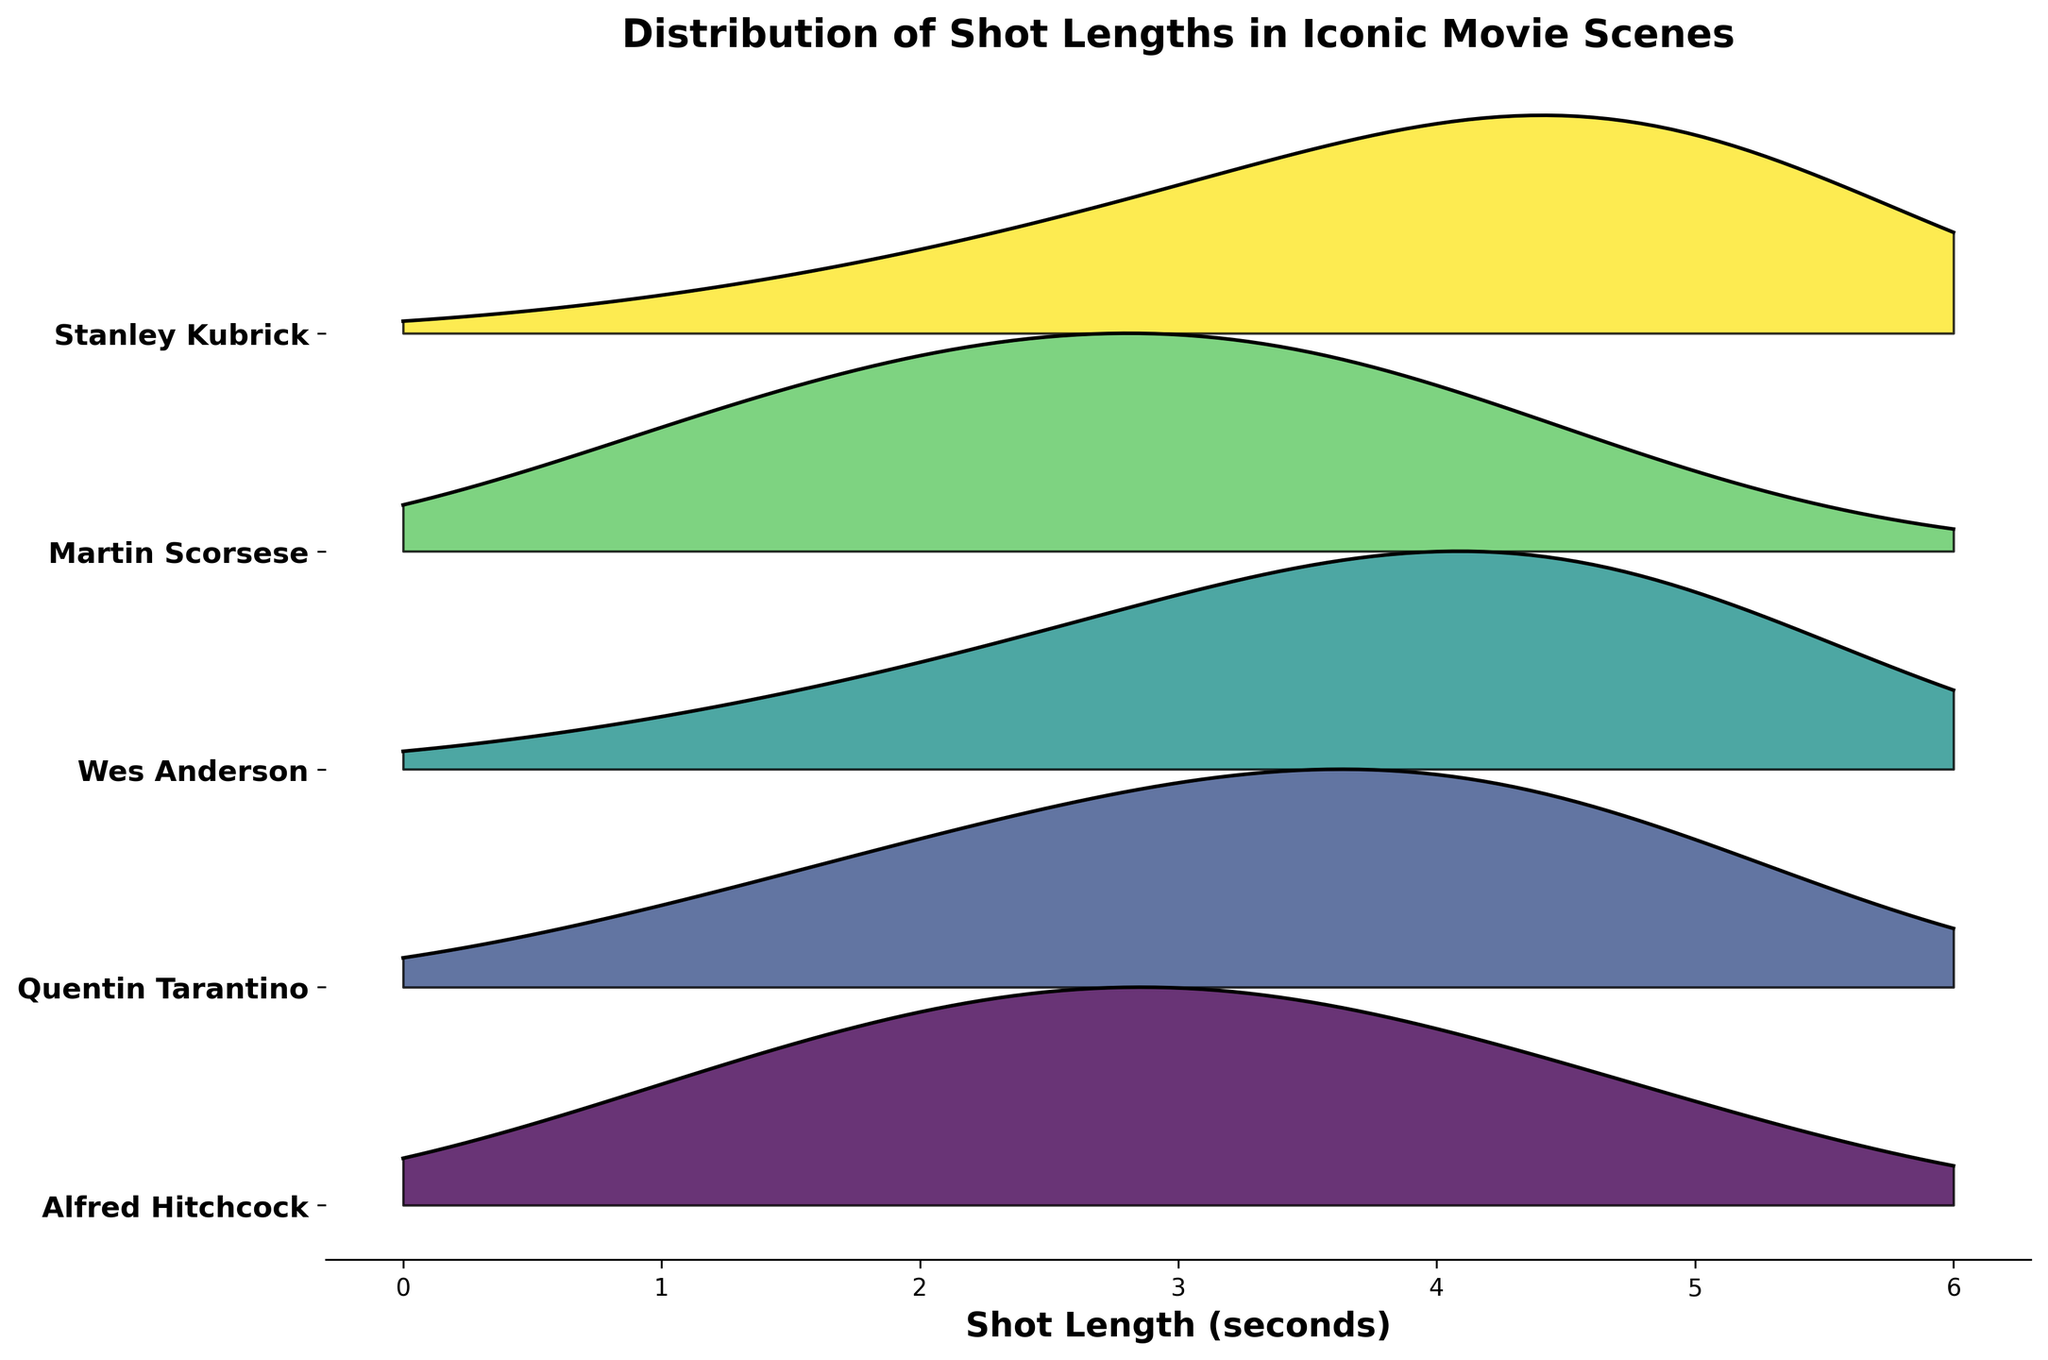What is the title of the figure? The title can be found at the top of the figure and usually summarizes the main topic or insight being presented.
Answer: Distribution of Shot Lengths in Iconic Movie Scenes Which director has the highest frequency for the shortest shot length? Inspect the ridgeline plot for the highest peaks at the shortest shot length, which in this case is 1 second. Count the frequency of the highest director.
Answer: Alfred Hitchcock What is the shot length with the highest frequency in Wes Anderson's data? Look at the shape of the ridgeline for Wes Anderson and identify the highest peak or density. Follow the x-axis to locate the corresponding shot length in seconds.
Answer: 4 seconds How do Quentin Tarantino's shot length distributions compare to Alfred Hitchcock's? Observe the ridgeline plots of both directors, specifically comparing the peaks and distributions of shot lengths. Quentin Tarantino shows higher frequencies for longer shot lengths than Alfred Hitchcock.
Answer: Longer shot lengths are more frequent What is the range of shot lengths examined in this figure? Identify the minimum and maximum values along the x-axis, which represent the shot lengths in the figure.
Answer: 1 to 5 seconds Which director has the most even distribution of shot lengths? Analyze the ridgeline plots for each director to see which has a more uniform spread without a pronounced peak. Stanley Kubrick's plot demonstrates a more even distribution across different shot lengths.
Answer: Stanley Kubrick Among the directors, who uses the longest shot length most frequently? Examine the peaks in the ridgeline plots and identify which director has the highest peak around the longest shot length, which is 5 seconds.
Answer: Stanley Kubrick How many directors have a peak frequency at a shot length of 3 seconds? Count the number of ridgeline plots that have their highest peak or one of the main peaks at the 3-second mark on the x-axis. Four directors (Alfred Hitchcock, Quentin Tarantino, Wes Anderson, Martin Scorsese) have a notable peak at 3 seconds.
Answer: 4 directors What can be inferred about Martin Scorsese's shot length preferences? Look at the shape of Martin Scorsese's ridgeline to determine where the highest frequencies are. It shows a notable high frequency at 3 seconds but drops significantly at longer shot lengths.
Answer: Prefers 3-second shots What common trend can be observed among these directors regarding their use of shot lengths? Identify if there is a commonality in the ridgeline plots that might indicate a shared tendency among the directors. Several directors show notable peaks at 3 and 4 seconds, suggesting these shot lengths are popular choices.
Answer: Peaks at 3 and 4 seconds 